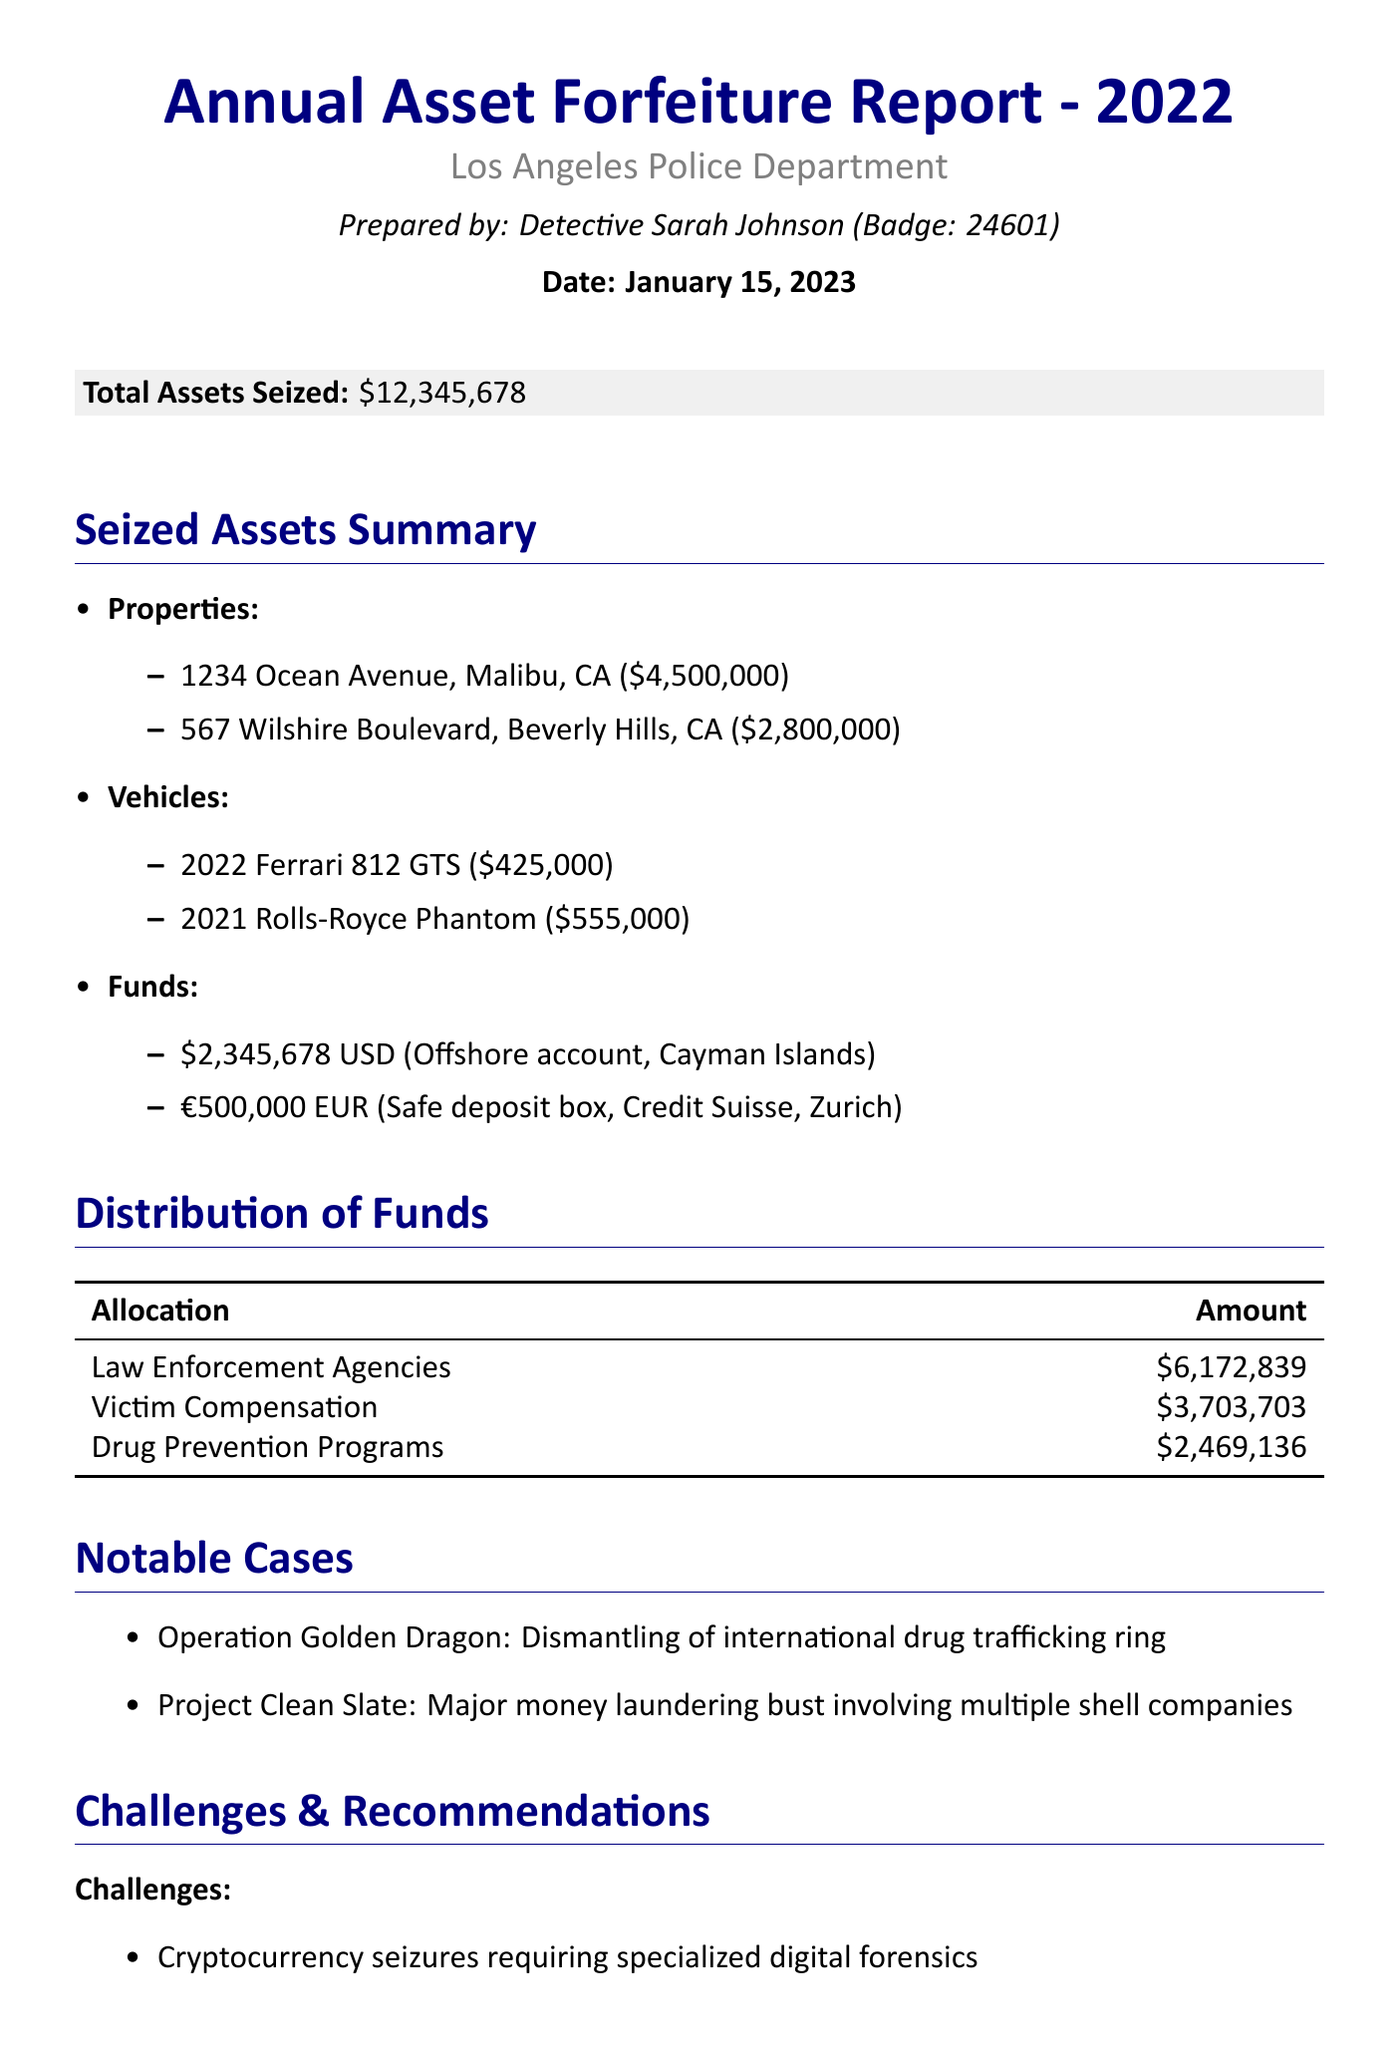what is the total assets seized? The total assets seized is stated explicitly in the document.
Answer: $12,345,678 who prepared the report? The reporting officer's name is mentioned at the beginning of the document.
Answer: Detective Sarah Johnson what is the estimated value of the property located at 567 Wilshire Boulevard? This value is detailed under the seized properties section of the report.
Answer: $2,800,000 which criminal is associated with the 2022 Ferrari 812 GTS? The associated criminal is listed next to the vehicle in the seized vehicles section.
Answer: James 'Lucky' Thompson what amount was distributed for victim compensation? This amount is clearly listed in the distribution of funds table.
Answer: $3,703,703 how much seized funds came from the offshore bank account in Cayman Islands? The source of the seized funds is specified in the report.
Answer: $2,345,678 what are the notable cases mentioned in the report? The notable cases are explicitly summarized in a list format in the document.
Answer: Operation Golden Dragon, Project Clean Slate what challenge is mentioned related to cryptocurrency? The challenge faced is specified in the challenges section of the report.
Answer: Cryptocurrency seizures requiring specialized digital forensics what is one recommendation for future actions mentioned? Future recommendations are highlighted; one of them can be extracted directly.
Answer: Enhance training for officers in identifying and seizing digital assets 